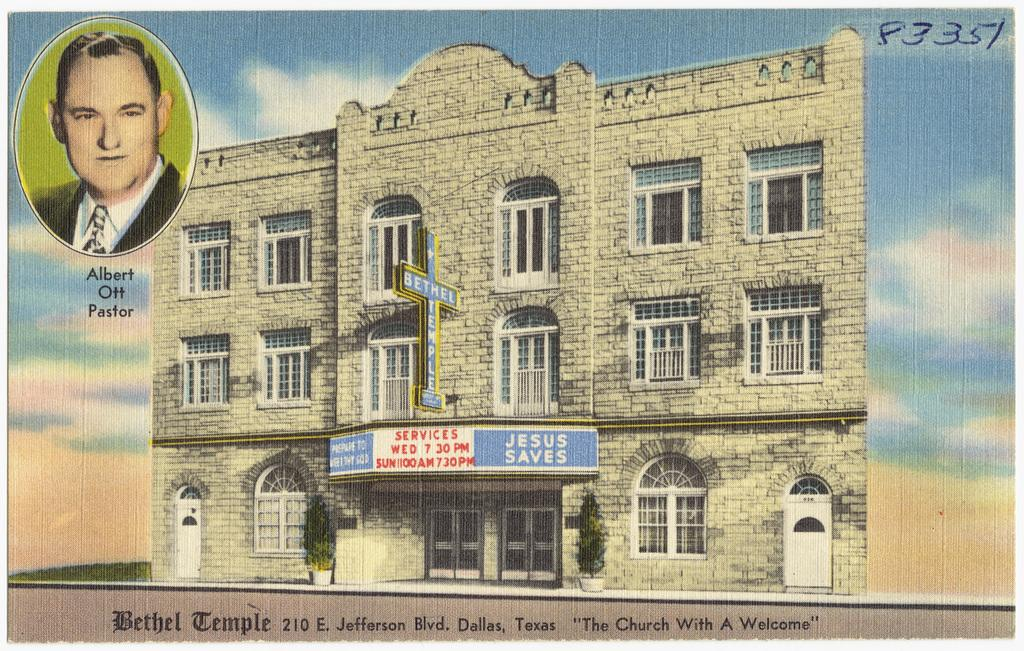What is featured on the poster in the image? The poster contains an image of a building and an image of a person. What else can be found on the poster besides the images? There is text on the poster. How many eggs are visible on the poster in the image? There are no eggs present on the poster in the image. Can you tell me what type of needle is being used by the person on the poster? There is no needle visible in the image, as the poster only contains an image of a person and a building, along with text. 